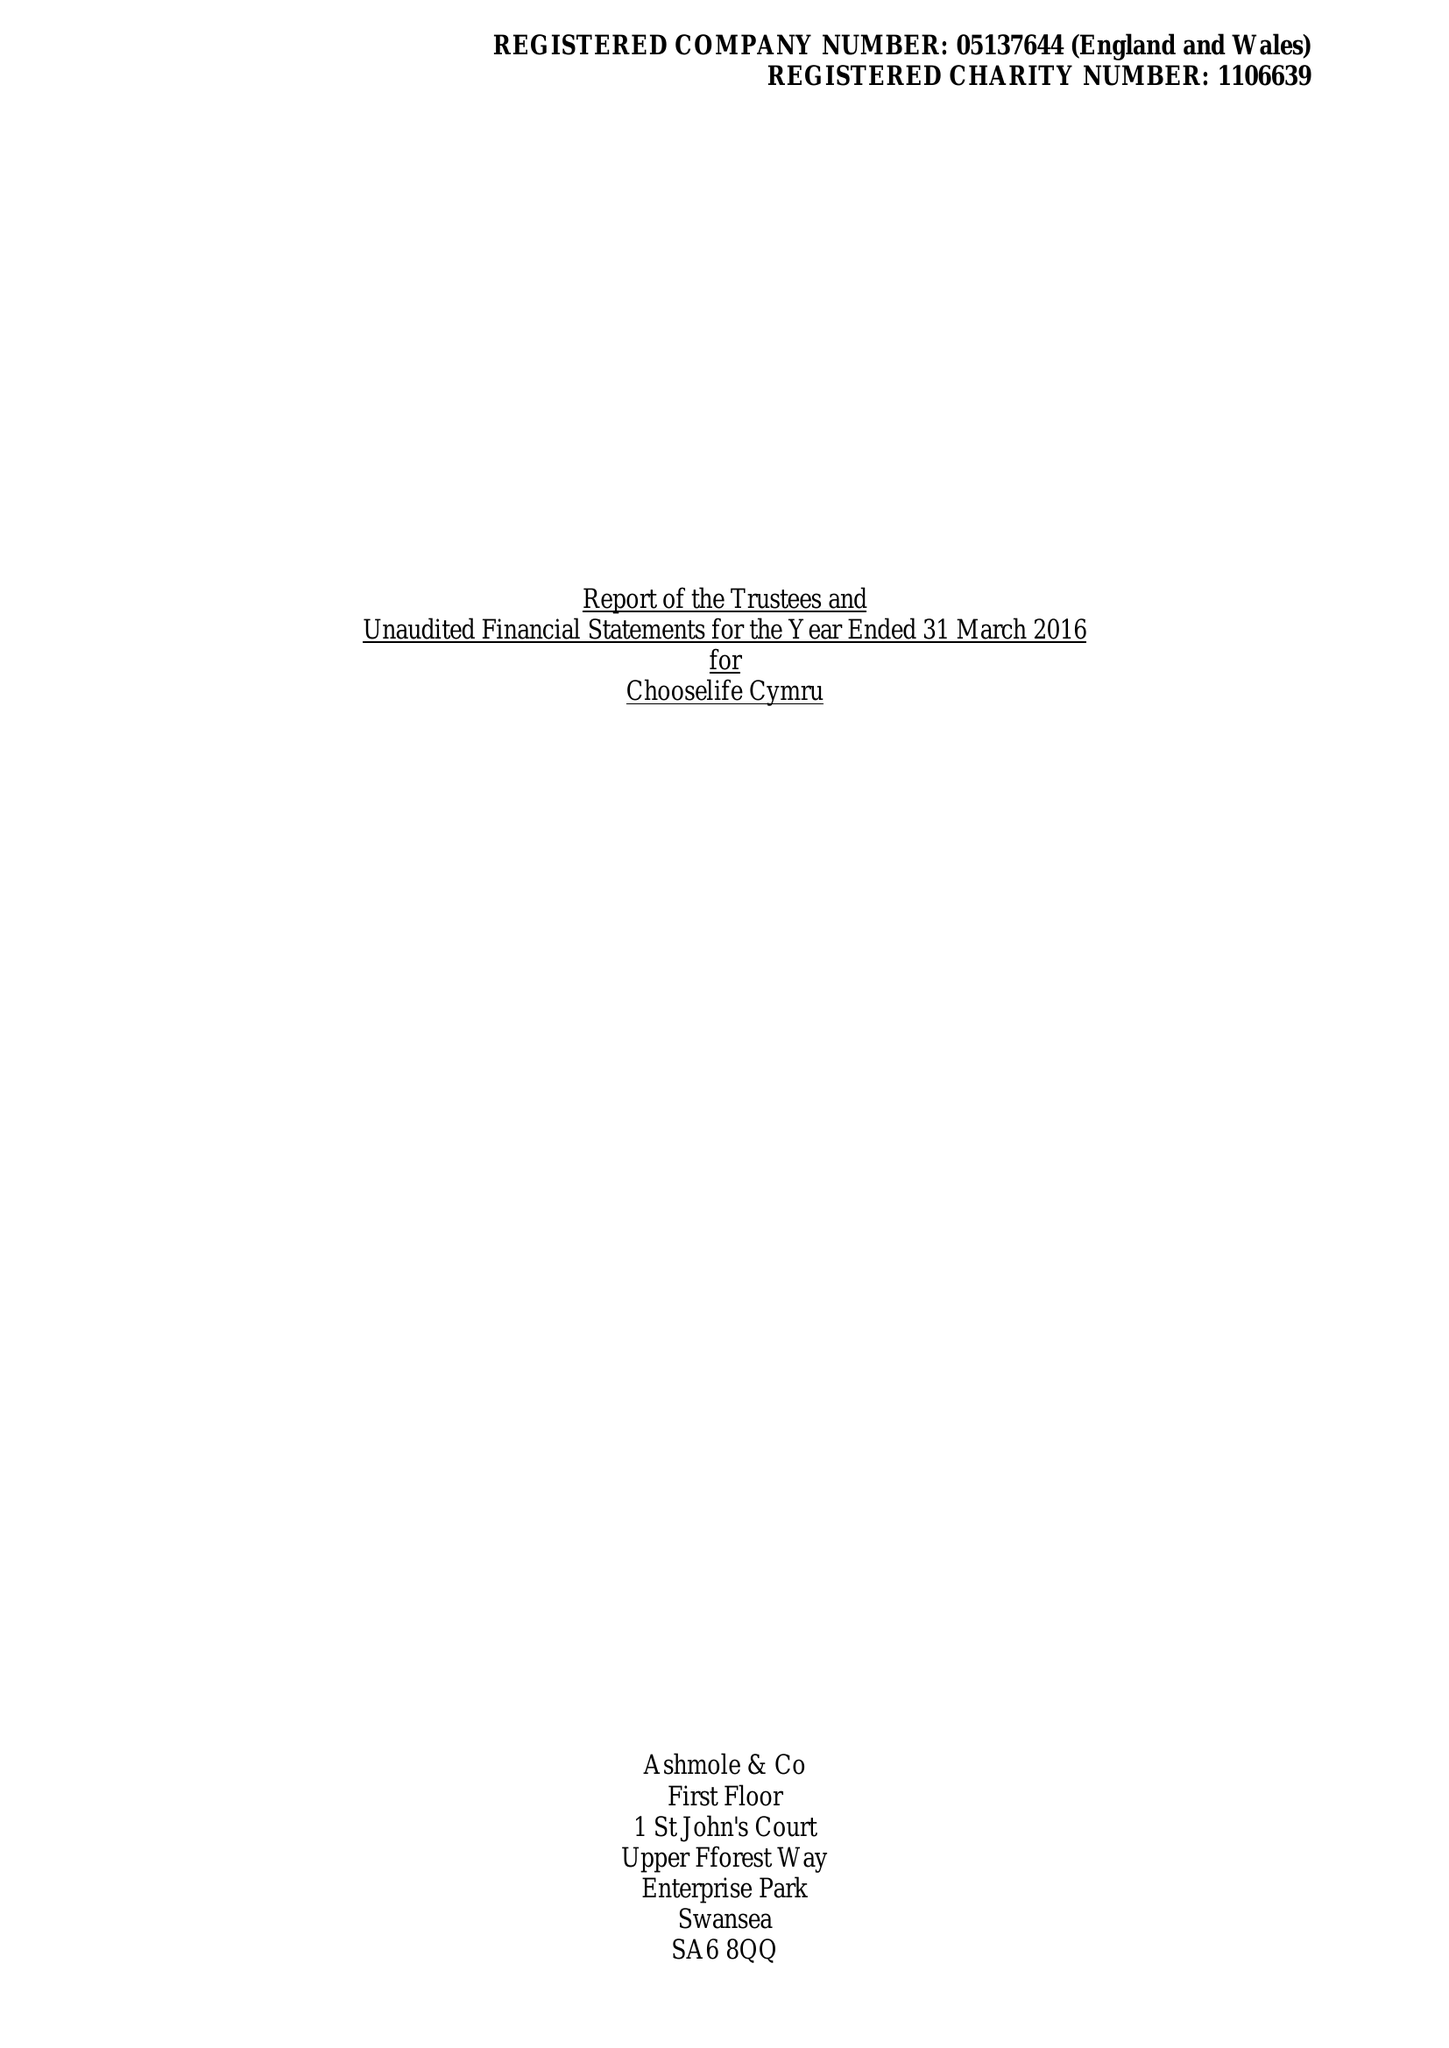What is the value for the address__postcode?
Answer the question using a single word or phrase. SA15 2NE 